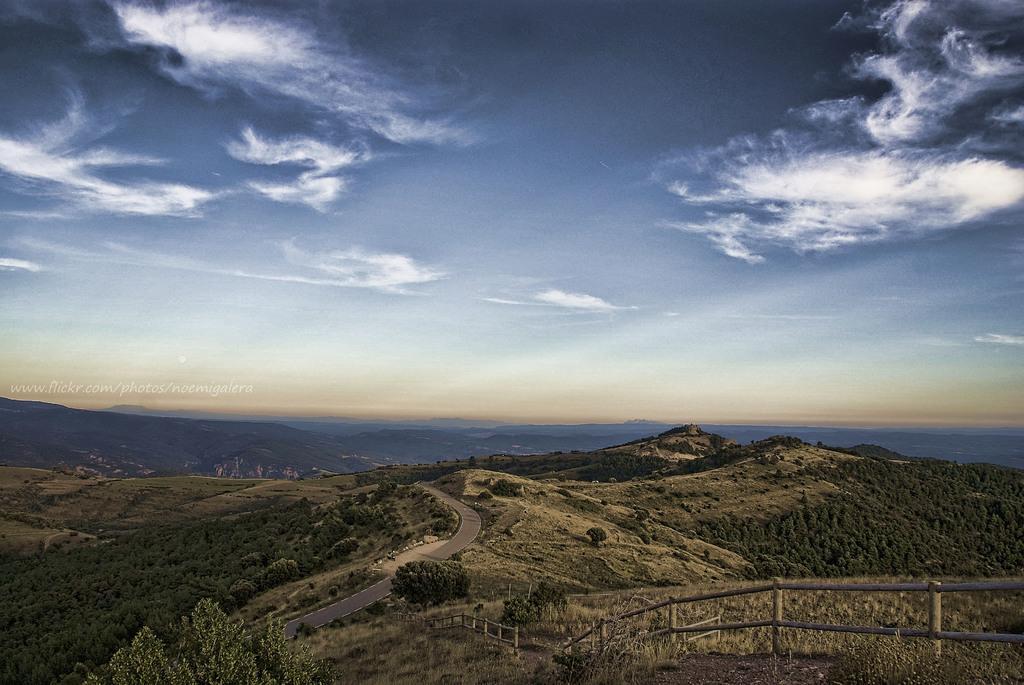Please provide a concise description of this image. In this image I can see a fence, trees, mountains and a text. At the top I can see the sky. This image is taken may be near the mountains. 